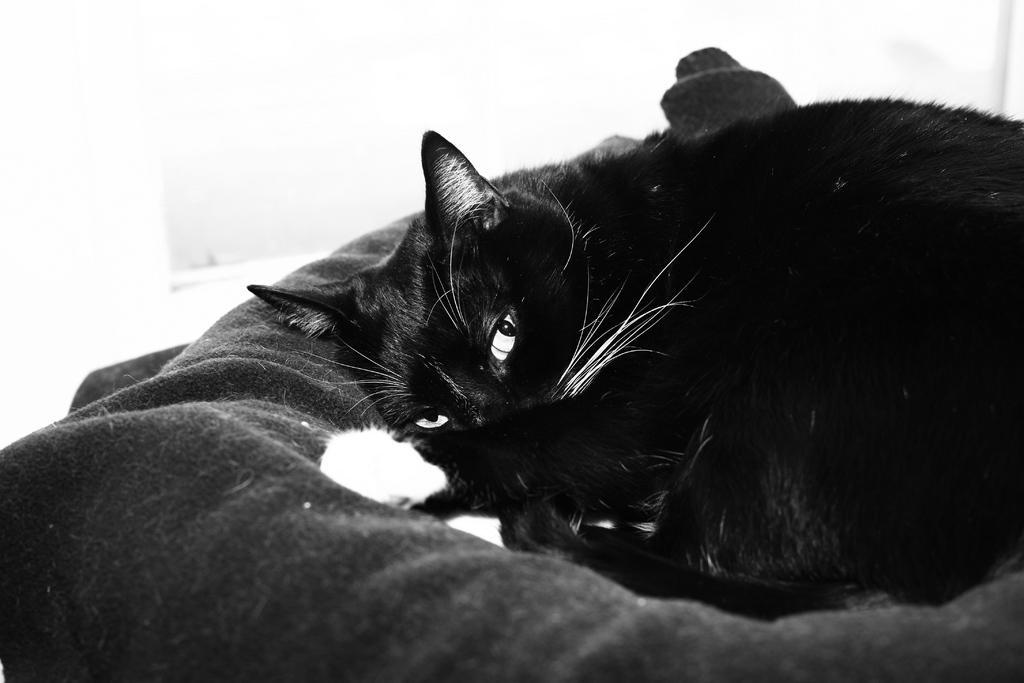Could you give a brief overview of what you see in this image? In this image I can see an animal on the cloth. I can see this is a black and white image. 